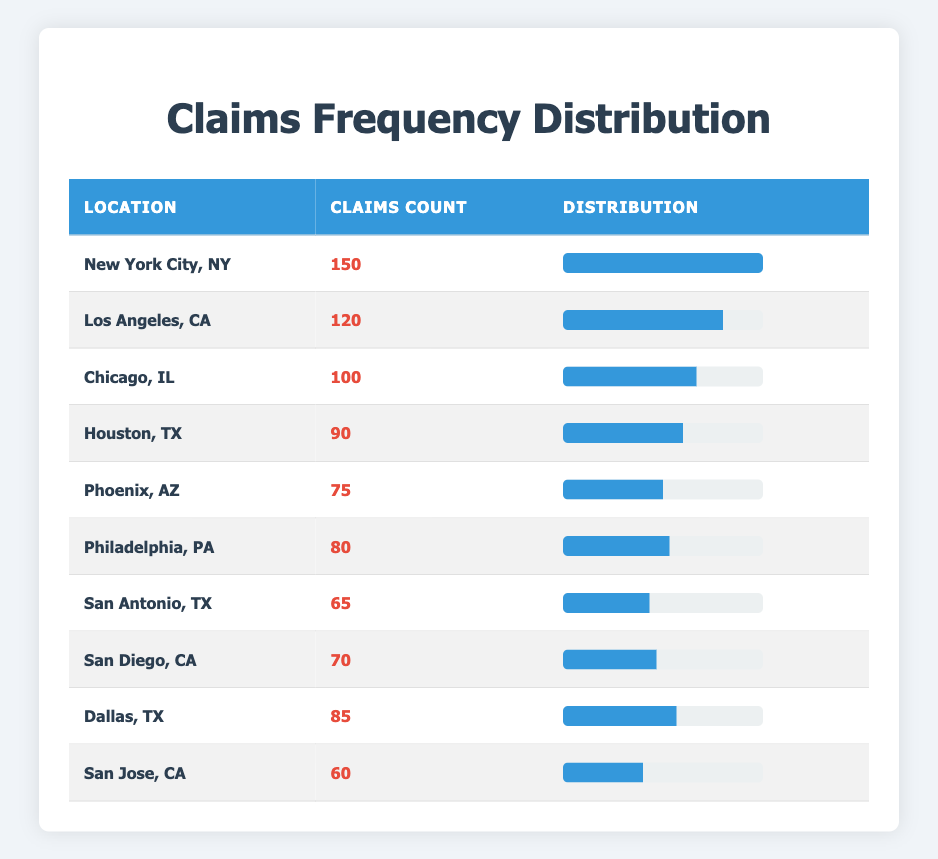What is the location with the highest frequency of claims? The table shows that New York City, NY has the highest claims count of 150. By scanning through the claims count, it is the maximum value compared to others.
Answer: New York City, NY How many claims were reported from Los Angeles, CA? Looking at the row for Los Angeles, CA, the claims count is explicitly stated as 120.
Answer: 120 Which location has the lowest number of claims? The table indicates that San Jose, CA has the lowest claims count of 60. By comparing all values, San Jose, CA is the minimum.
Answer: San Jose, CA What is the total number of claims for Houston, TX, and Dallas, TX combined? Summing the claims for Houston (90) and Dallas (85), we have 90 + 85 = 175. Therefore, the total number of claims for these two locations is obtained by direct addition.
Answer: 175 Is the total claims count for San Antonio, TX greater than that for Phoenix, AZ? The claims count for San Antonio is 65 and for Phoenix is 75. Since 65 is less than 75, the statement is false. This requires comparison between the two numbers to reach a conclusion.
Answer: No What is the average number of claims for the locations listed? The average is calculated by adding all claims counts: (150 + 120 + 100 + 90 + 75 + 80 + 65 + 70 + 85 + 60) = 1010. Dividing by the number of locations (10), the average is 1010 / 10 = 101. The steps include summing all claims and dividing by the count of locations.
Answer: 101 How many locations reported fewer than 80 claims? Scanning through the claims, locations with fewer than 80 claims are San Antonio (65), San Diego (70), and San Jose (60), totaling 3 such locations. This involves checking each entry against the number 80 and counting.
Answer: 3 What is the difference in claims count between Chicago, IL and Philadelphia, PA? Chicago has 100 claims and Philadelphia has 80. The difference is computed as 100 - 80 = 20. This requires subtraction to find the value.
Answer: 20 